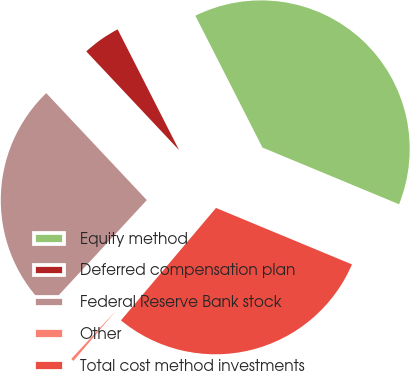Convert chart to OTSL. <chart><loc_0><loc_0><loc_500><loc_500><pie_chart><fcel>Equity method<fcel>Deferred compensation plan<fcel>Federal Reserve Bank stock<fcel>Other<fcel>Total cost method investments<nl><fcel>38.76%<fcel>4.52%<fcel>26.1%<fcel>0.72%<fcel>29.91%<nl></chart> 